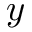Convert formula to latex. <formula><loc_0><loc_0><loc_500><loc_500>y</formula> 